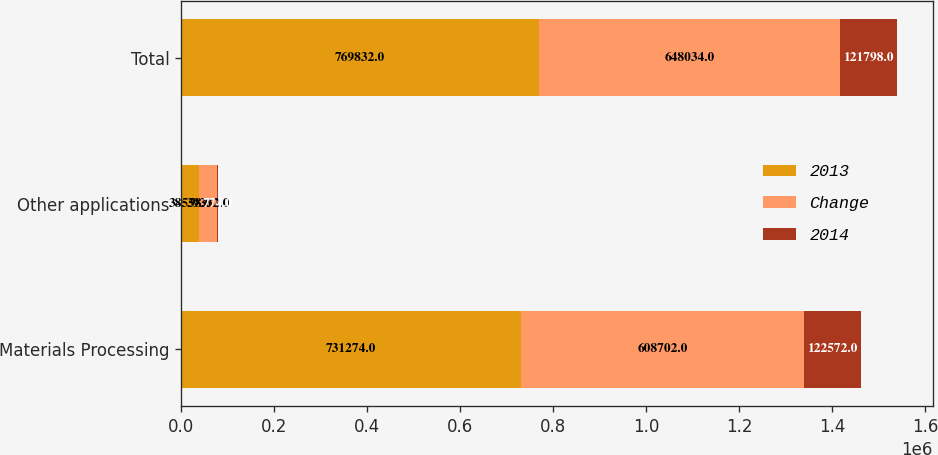Convert chart. <chart><loc_0><loc_0><loc_500><loc_500><stacked_bar_chart><ecel><fcel>Materials Processing<fcel>Other applications<fcel>Total<nl><fcel>2013<fcel>731274<fcel>38558<fcel>769832<nl><fcel>Change<fcel>608702<fcel>39332<fcel>648034<nl><fcel>2014<fcel>122572<fcel>774<fcel>121798<nl></chart> 